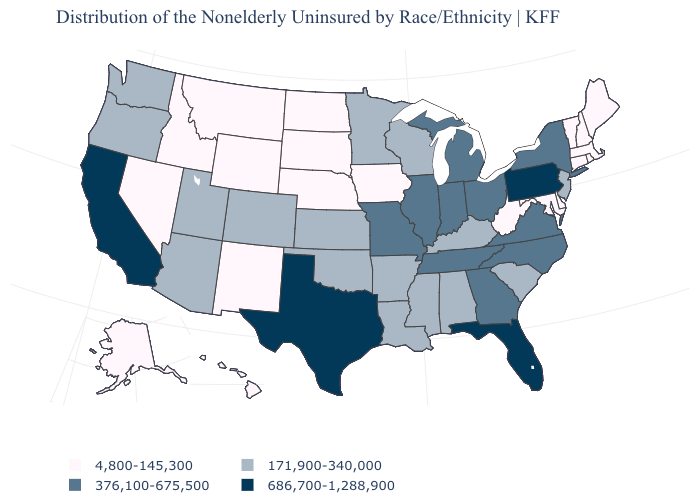Name the states that have a value in the range 171,900-340,000?
Write a very short answer. Alabama, Arizona, Arkansas, Colorado, Kansas, Kentucky, Louisiana, Minnesota, Mississippi, New Jersey, Oklahoma, Oregon, South Carolina, Utah, Washington, Wisconsin. Name the states that have a value in the range 171,900-340,000?
Write a very short answer. Alabama, Arizona, Arkansas, Colorado, Kansas, Kentucky, Louisiana, Minnesota, Mississippi, New Jersey, Oklahoma, Oregon, South Carolina, Utah, Washington, Wisconsin. Among the states that border Nebraska , which have the highest value?
Answer briefly. Missouri. What is the highest value in states that border Texas?
Answer briefly. 171,900-340,000. What is the value of Washington?
Keep it brief. 171,900-340,000. Does New Mexico have the lowest value in the USA?
Concise answer only. Yes. What is the value of California?
Answer briefly. 686,700-1,288,900. Which states hav the highest value in the MidWest?
Answer briefly. Illinois, Indiana, Michigan, Missouri, Ohio. Name the states that have a value in the range 376,100-675,500?
Write a very short answer. Georgia, Illinois, Indiana, Michigan, Missouri, New York, North Carolina, Ohio, Tennessee, Virginia. Which states have the lowest value in the USA?
Keep it brief. Alaska, Connecticut, Delaware, Hawaii, Idaho, Iowa, Maine, Maryland, Massachusetts, Montana, Nebraska, Nevada, New Hampshire, New Mexico, North Dakota, Rhode Island, South Dakota, Vermont, West Virginia, Wyoming. What is the value of New Mexico?
Give a very brief answer. 4,800-145,300. Name the states that have a value in the range 171,900-340,000?
Short answer required. Alabama, Arizona, Arkansas, Colorado, Kansas, Kentucky, Louisiana, Minnesota, Mississippi, New Jersey, Oklahoma, Oregon, South Carolina, Utah, Washington, Wisconsin. What is the value of Alaska?
Short answer required. 4,800-145,300. What is the value of California?
Give a very brief answer. 686,700-1,288,900. Name the states that have a value in the range 686,700-1,288,900?
Keep it brief. California, Florida, Pennsylvania, Texas. 